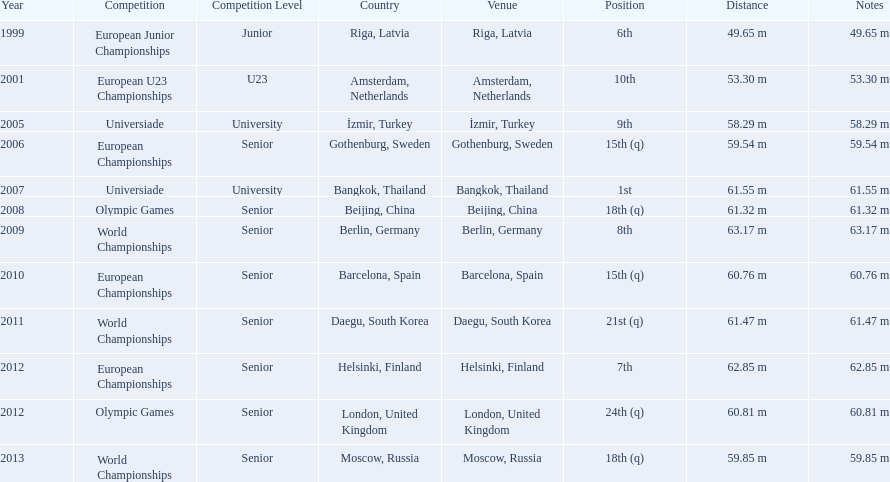Prior to 2007, what was the highest place achieved? 6th. 